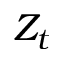<formula> <loc_0><loc_0><loc_500><loc_500>Z _ { t }</formula> 